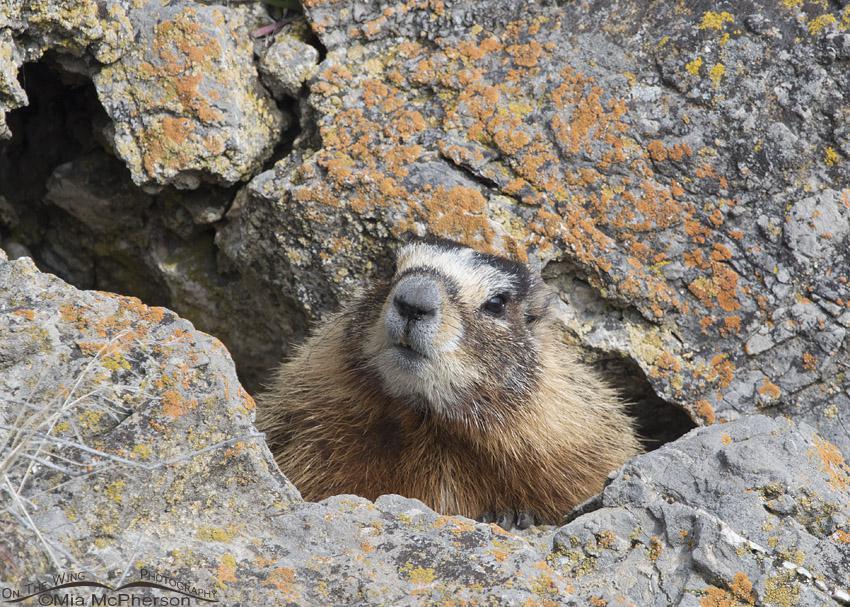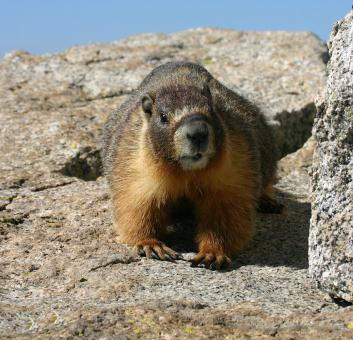The first image is the image on the left, the second image is the image on the right. Given the left and right images, does the statement "A marmot is emerging from a crevice, with rocks above and below the animal." hold true? Answer yes or no. Yes. The first image is the image on the left, the second image is the image on the right. For the images shown, is this caption "One of the animals is facing towards the left." true? Answer yes or no. No. The first image is the image on the left, the second image is the image on the right. Assess this claim about the two images: "The rodent in the right image is looking towards the right.". Correct or not? Answer yes or no. No. The first image is the image on the left, the second image is the image on the right. Evaluate the accuracy of this statement regarding the images: "Two marmots are facing in opposite directions". Is it true? Answer yes or no. No. 